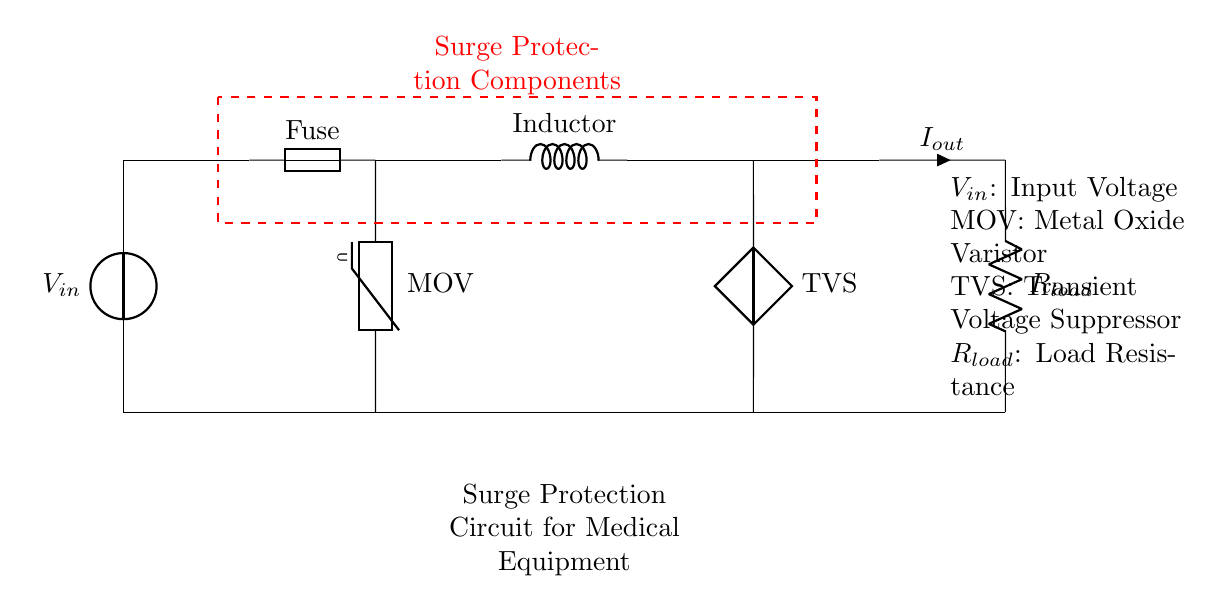What is the input voltage of the circuit? The input voltage, labeled as V in the circuit diagram, is the voltage being supplied to the circuit's components. It is shown at the beginning of the circuit diagram as the source.
Answer: V in What component provides surge protection? The circuit includes two key components for surge protection: the Metal Oxide Varistor and the Transient Voltage Suppressor. Both of these components are responsible for mitigating voltage spikes and protecting sensitive equipment.
Answer: MOV and TVS How many branches does the circuit have? The circuit has two branches that occur after the input voltage; one goes through the varistor and then to the load, while the other includes the inductor and TVS. The split signifies that there are two paths for managing the current.
Answer: Two What is the role of the fuse in this circuit? The fuse is a safety device that protects the circuit from overcurrent. If the current exceeds a certain threshold, the fuse will blow, disconnecting the circuit and preventing damage to downstream components.
Answer: Safety device What could happen if the varistor fails? If the Metal Oxide Varistor fails, it could result in failure to clamp transient voltages, exposing sensitive medical equipment to potentially damaging surges, which could lead to malfunction or damage to the equipment.
Answer: Equipment damage What is the load resistance in the circuit? The load resistance, indicated as R load, is a component of the circuit that consumes power. Its specific value is not shown in the diagram, but it is essential for determining the total current flowing through the circuit.
Answer: R load 